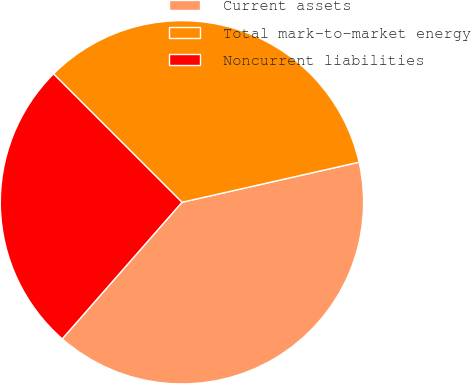Convert chart. <chart><loc_0><loc_0><loc_500><loc_500><pie_chart><fcel>Current assets<fcel>Total mark-to-market energy<fcel>Noncurrent liabilities<nl><fcel>40.0%<fcel>33.96%<fcel>26.04%<nl></chart> 